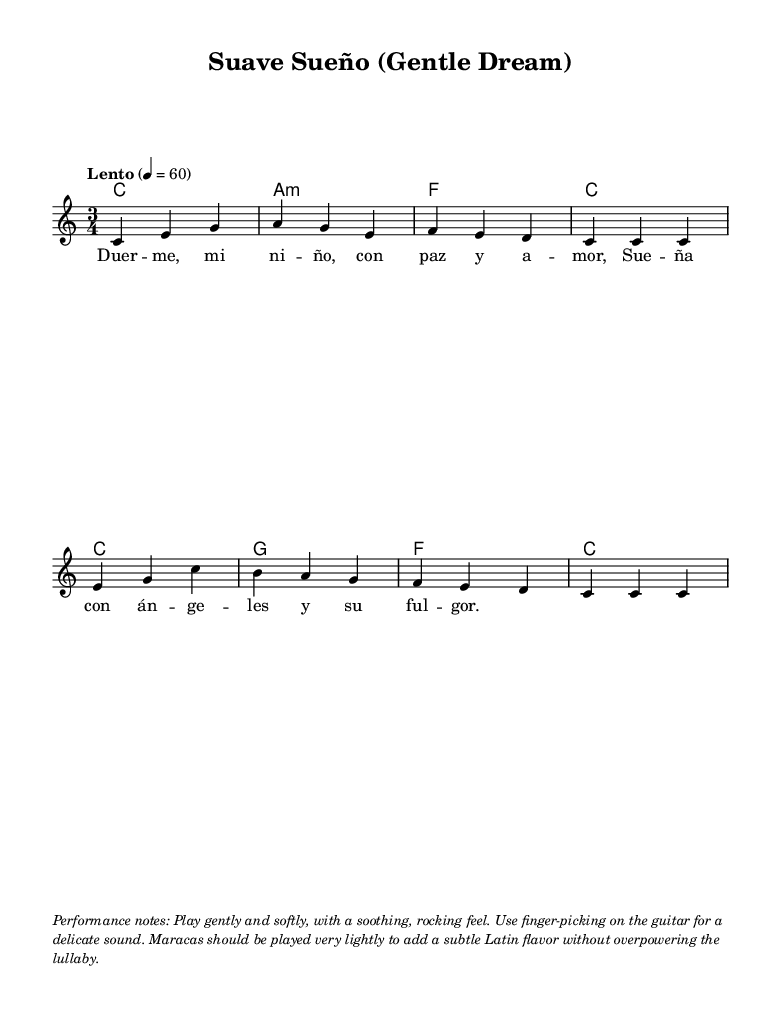What is the key signature of this music? The key signature is indicated by the absence of sharps or flats at the beginning of the staff. This identifies the piece as being in C major.
Answer: C major What is the time signature of this music? The time signature is located near the beginning of the sheet music, indicated by the "3/4" notation, which signifies three beats per measure, with each beat being a quarter note.
Answer: 3/4 What is the tempo marking for this piece? The tempo is defined in Italian as "Lento," which means slow, and is indicated on the score along with a metronome mark of 60 beats per minute, suggesting a calm pace.
Answer: Lento How many measures are there in the melody section? By counting the vertical bar lines in the melody part, we can see there are a total of eight measures highlighted, each separated by a bar line.
Answer: 8 What type of musical ensemble is indicated for this composition? The score included a new staff and voice designation, which implies it is composed for a single instrument, typically a solo performer. The presence of chord names suggests it could also be accompanied by guitar.
Answer: Solo voice and guitar What notable performance technique is suggested in the performance notes? The performance notes suggest using finger-picking on the guitar, which implies a specific technique for producing sound subtly and delicately, as mentioned in the performance notes.
Answer: Finger-picking What language are the lyrics of this lullaby written in? The lyrics provided in the lyrics section of the score are written in Spanish, indicated by words like "Duerme" and "niño," which are Spanish for "sleep" and "child," respectively.
Answer: Spanish 